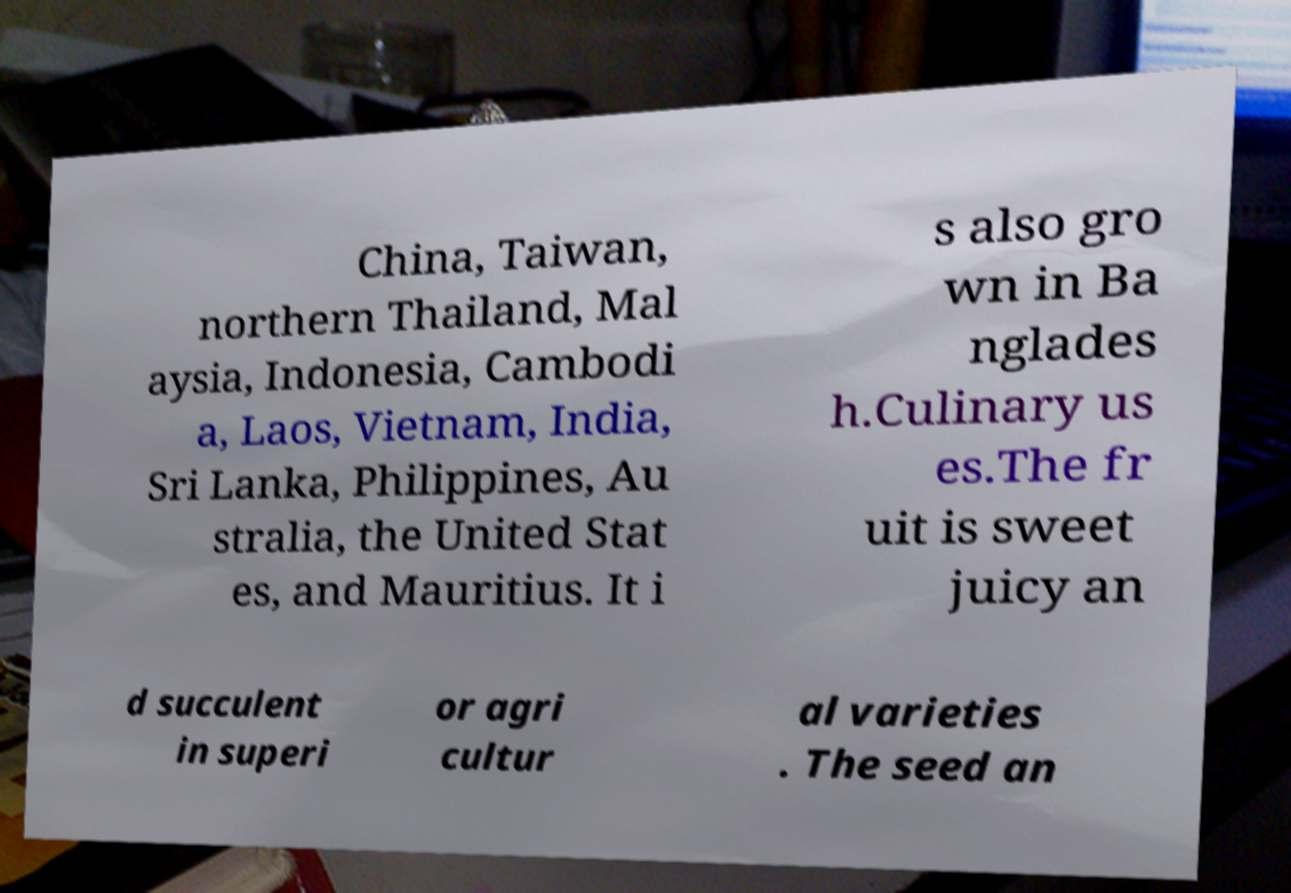There's text embedded in this image that I need extracted. Can you transcribe it verbatim? China, Taiwan, northern Thailand, Mal aysia, Indonesia, Cambodi a, Laos, Vietnam, India, Sri Lanka, Philippines, Au stralia, the United Stat es, and Mauritius. It i s also gro wn in Ba nglades h.Culinary us es.The fr uit is sweet juicy an d succulent in superi or agri cultur al varieties . The seed an 